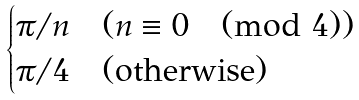<formula> <loc_0><loc_0><loc_500><loc_500>\begin{cases} \pi / n & ( n \equiv 0 \pmod { 4 } ) \\ \pi / 4 & ( \text {otherwise} ) \end{cases}</formula> 